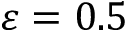<formula> <loc_0><loc_0><loc_500><loc_500>\varepsilon = 0 . 5</formula> 